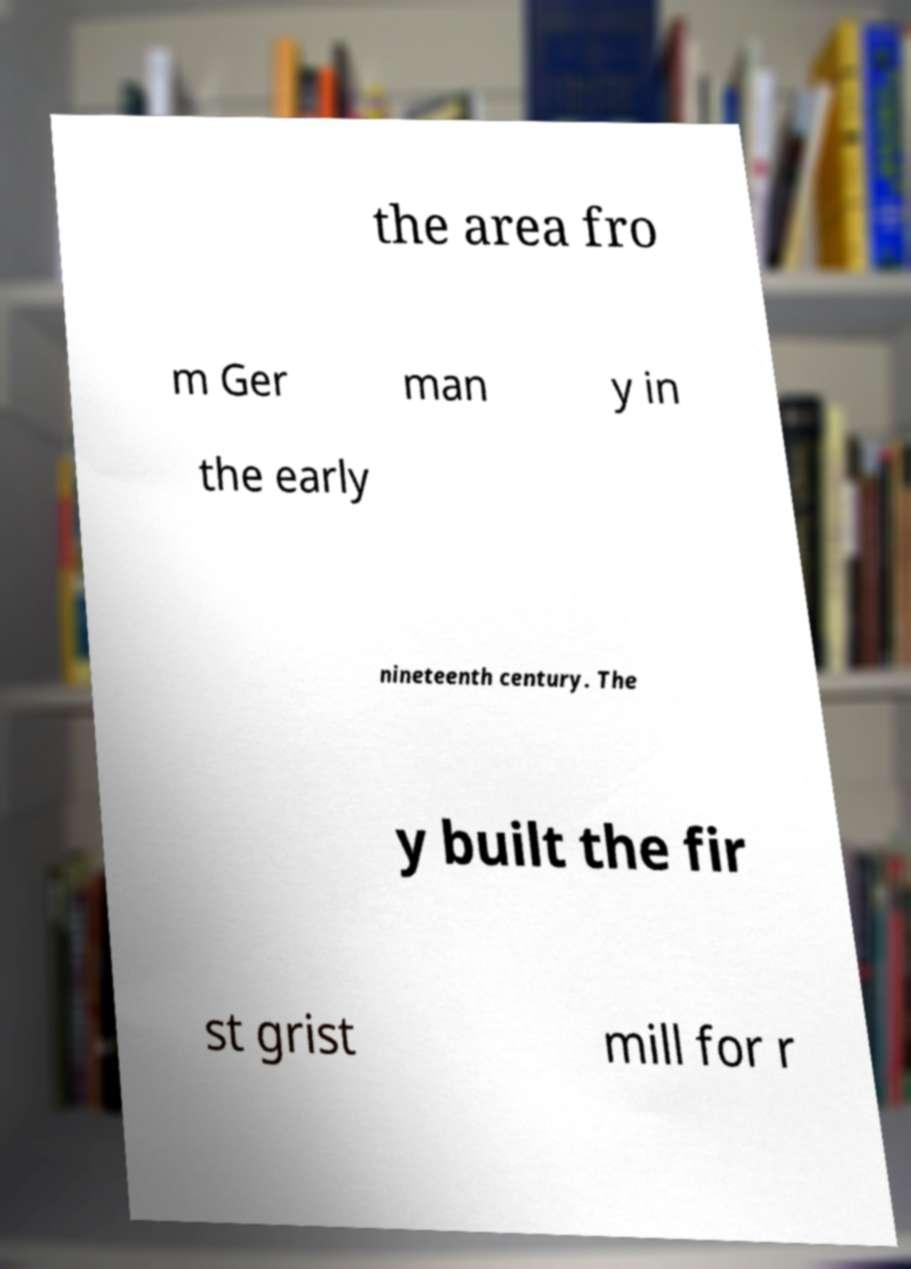Can you read and provide the text displayed in the image?This photo seems to have some interesting text. Can you extract and type it out for me? the area fro m Ger man y in the early nineteenth century. The y built the fir st grist mill for r 